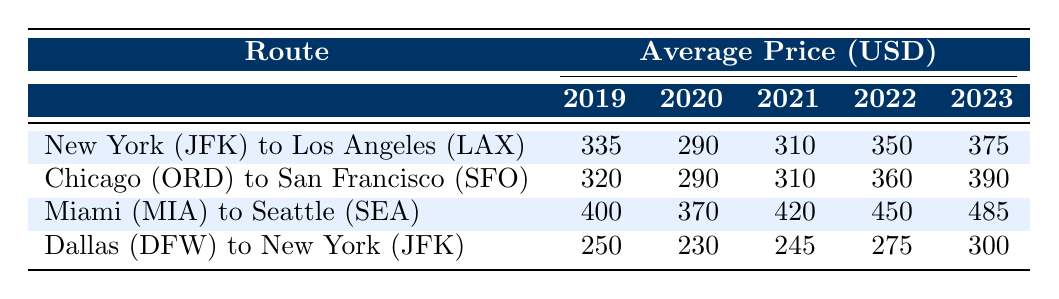What's the average airfare price from New York to Los Angeles in 2021? From the table, the average price for the route from New York (JFK) to Los Angeles (LAX) in 2021 is listed as 310 USD.
Answer: 310 What was the airfare price trend from 2019 to 2023 for the Miami to Seattle route? By looking at the prices for the route from Miami (MIA) to Seattle (SEA), the prices have increased from 400 USD in 2019 to 485 USD in 2023, indicating a steady upward trend over the years.
Answer: Increasing trend Which route had the highest average fare in 2023? In the table, Miami (MIA) to Seattle (SEA) has the highest price at 485 USD in 2023, compared to the other routes listed.
Answer: Miami to Seattle Is the average price from Dallas to New York consistently lower than 300 USD over the past five years? The prices for the Dallas (DFW) to New York (JFK) route were 250, 230, 245, 275, and 300 USD from 2019 to 2023. The price reached 300 USD in 2023, so it was consistently lower than or equal to 300 USD until 2023.
Answer: Yes What is the difference in the average airfare price from Chicago to San Francisco between 2019 and 2023? The average price for Chicago (ORD) to San Francisco (SFO) in 2019 was 320 USD and in 2023 it was 390 USD. The difference is calculated as 390 - 320 = 70 USD.
Answer: 70 What is the overall average fare for the Dallas to New York route over the past five years? The prices for the Dallas to New York route are 250, 230, 245, 275, and 300 USD. To find the average, we add these up (250 + 230 + 245 + 275 + 300 = 1300) and divide by 5, resulting in an average of 260 USD.
Answer: 260 Did airfares for the Miami to Seattle route decrease from 2019 to 2020? From the table, we see that the fare decreased from 400 USD in 2019 to 370 USD in 2020, indicating a decrease for that year.
Answer: Yes How much did the average price from New York to Los Angeles increase from 2020 to 2022? The average price for the route in 2020 was 290 USD, and in 2022 it was 350 USD. The increase is calculated as 350 - 290 = 60 USD.
Answer: 60 Which route experienced the most significant increase in average price from 2019 to 2023? Analyzing the increases, Miami to Seattle rose from 400 USD to 485 USD, an increase of 85 USD. Chicago to San Francisco rose from 320 USD to 390 USD, an increase of 70 USD. Therefore, Miami to Seattle experienced the most significant increase.
Answer: Miami to Seattle 